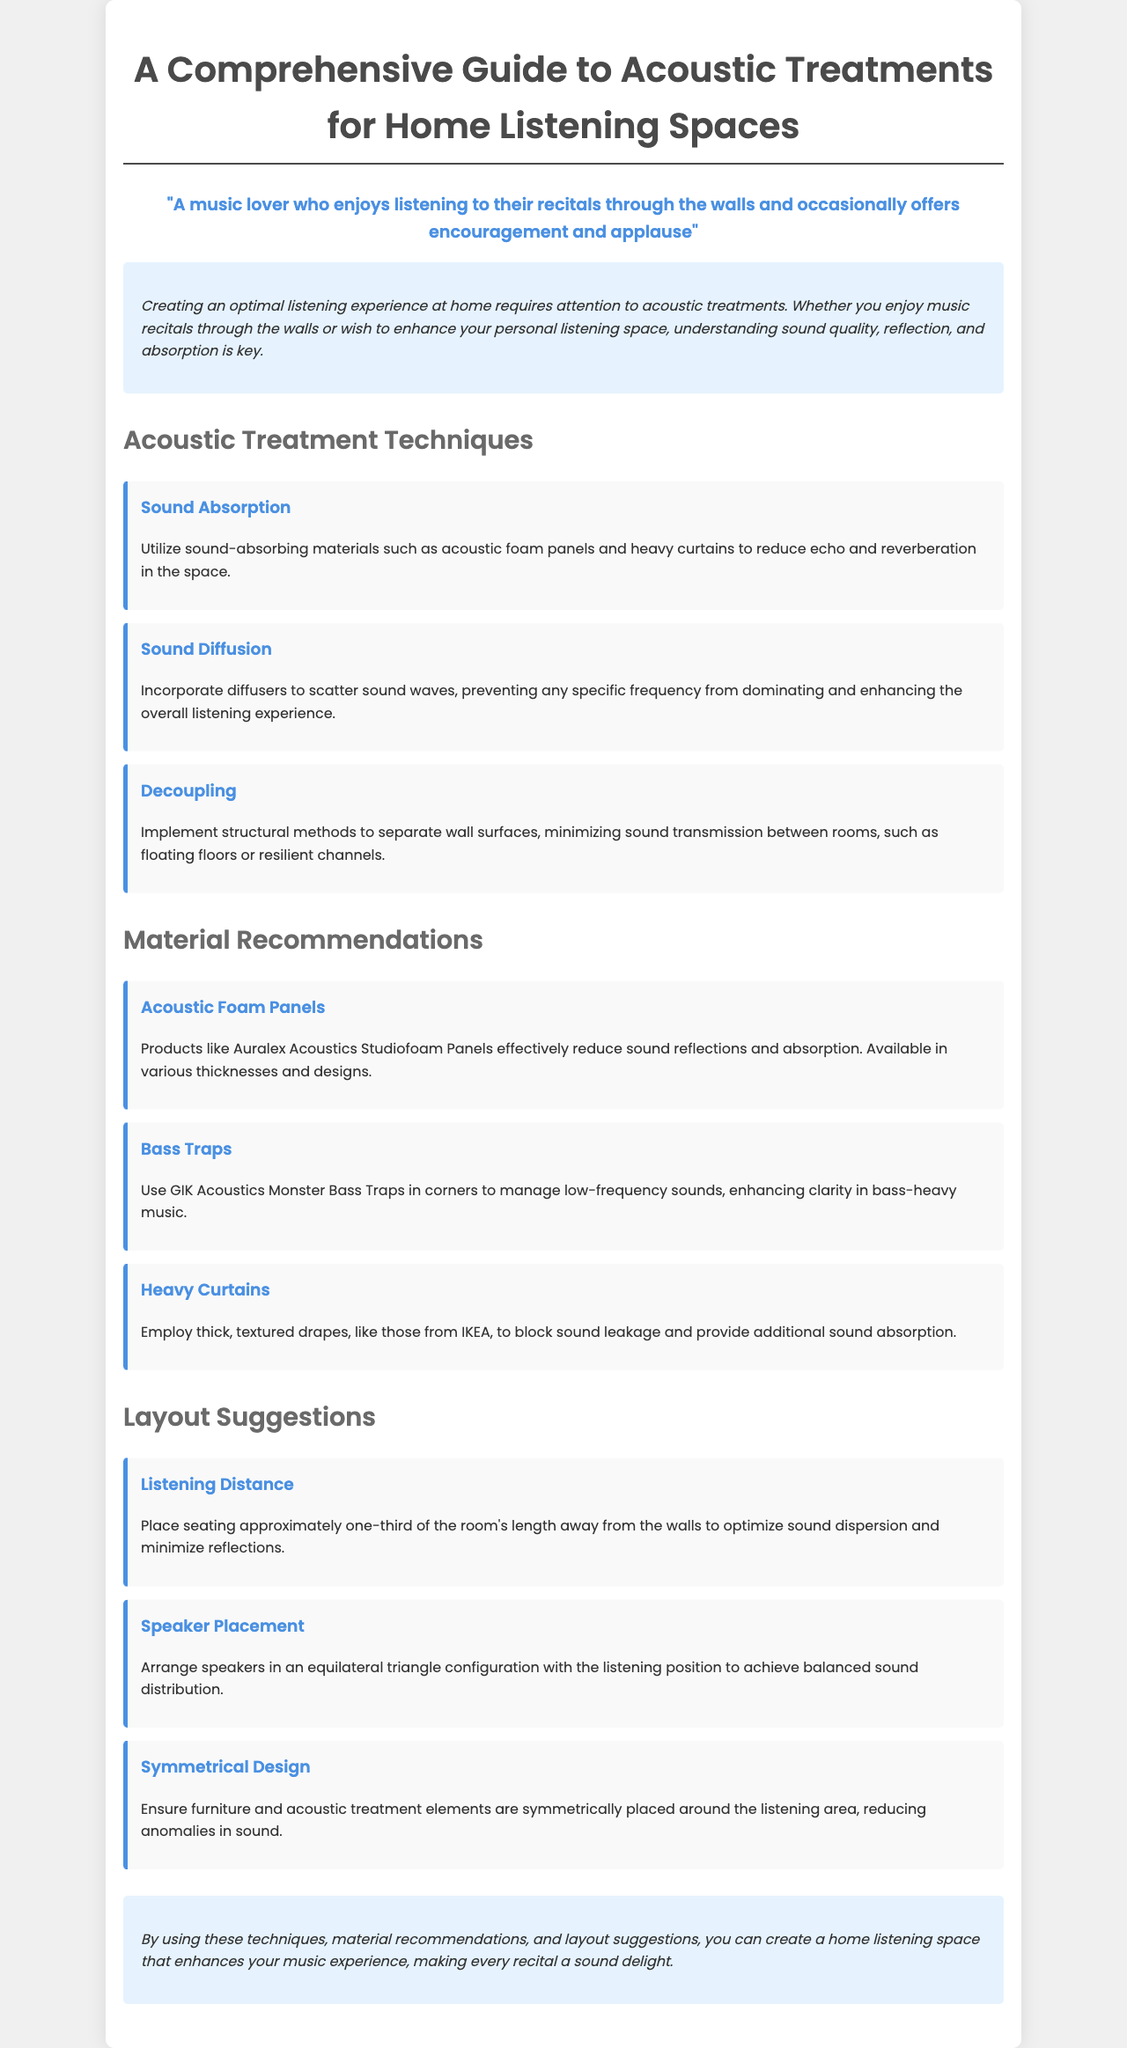What is the title of the document? The title of the document is displayed prominently at the top.
Answer: A Comprehensive Guide to Acoustic Treatments for Home Listening Spaces What technique focuses on reducing echo? The document lists specific techniques under the section on acoustic treatment.
Answer: Sound Absorption Which material is recommended for managing low-frequency sounds? The recommendation is provided in the material recommendations section.
Answer: Bass Traps How should speakers be arranged for balanced sound? The layout suggestions section explains the ideal setup for speakers.
Answer: Equilateral triangle What is suggested for blocking sound leakage in the document? The material recommendations give options for effective sound blocking.
Answer: Heavy Curtains What is the suggested listening distance from the walls? The layout suggestions provide specific measurements for optimal listening.
Answer: One-third of the room's length Which brand is mentioned for acoustic foam panels? The document provides branding information regarding specific material recommendations.
Answer: Auralex Acoustics What is the purpose of using diffusers according to the guide? The document explains the function of diffusers in the context of sound treatment.
Answer: Scatter sound waves What design principle is emphasized for reducing sound anomalies? The document discusses layout suggestions that focus on arranging elements around the listening area.
Answer: Symmetrical Design 